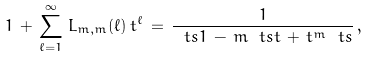<formula> <loc_0><loc_0><loc_500><loc_500>1 \, + \, \sum _ { \ell = 1 } ^ { \infty } \, L _ { m , m } ( \ell ) \, t ^ { \ell } \, = \, \frac { 1 } { \ t s 1 \, - \, m \ t s t \, + \, t ^ { m } \ t s } \, ,</formula> 